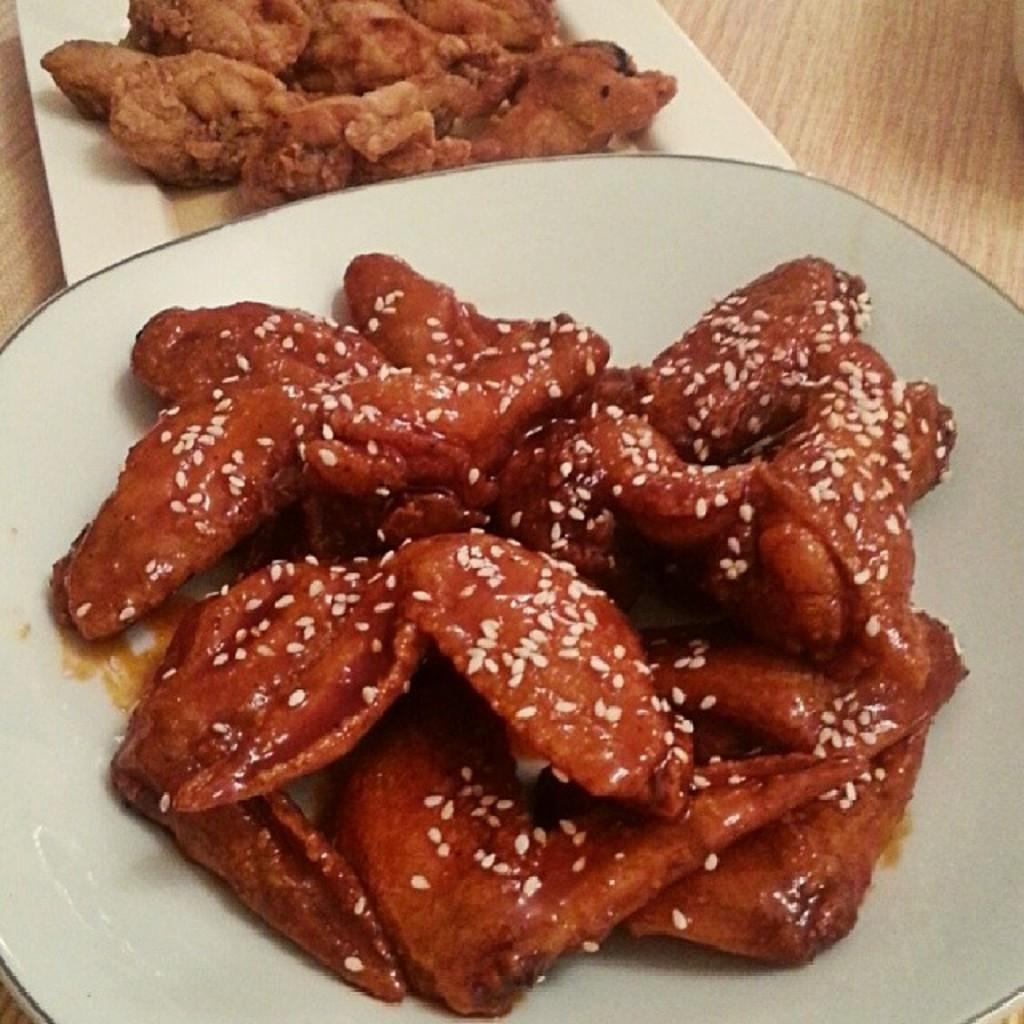How many plates are visible in the image? There are two plates in the image. What is on the plates? The plates contain food items. Where are the plates located? The plates are on a table. In which setting is the image taken? The image is taken in a room. What type of reaction does the kitten have to the food on the plates? There is no kitten present in the image, so it is not possible to determine any reaction to the food on the plates. 